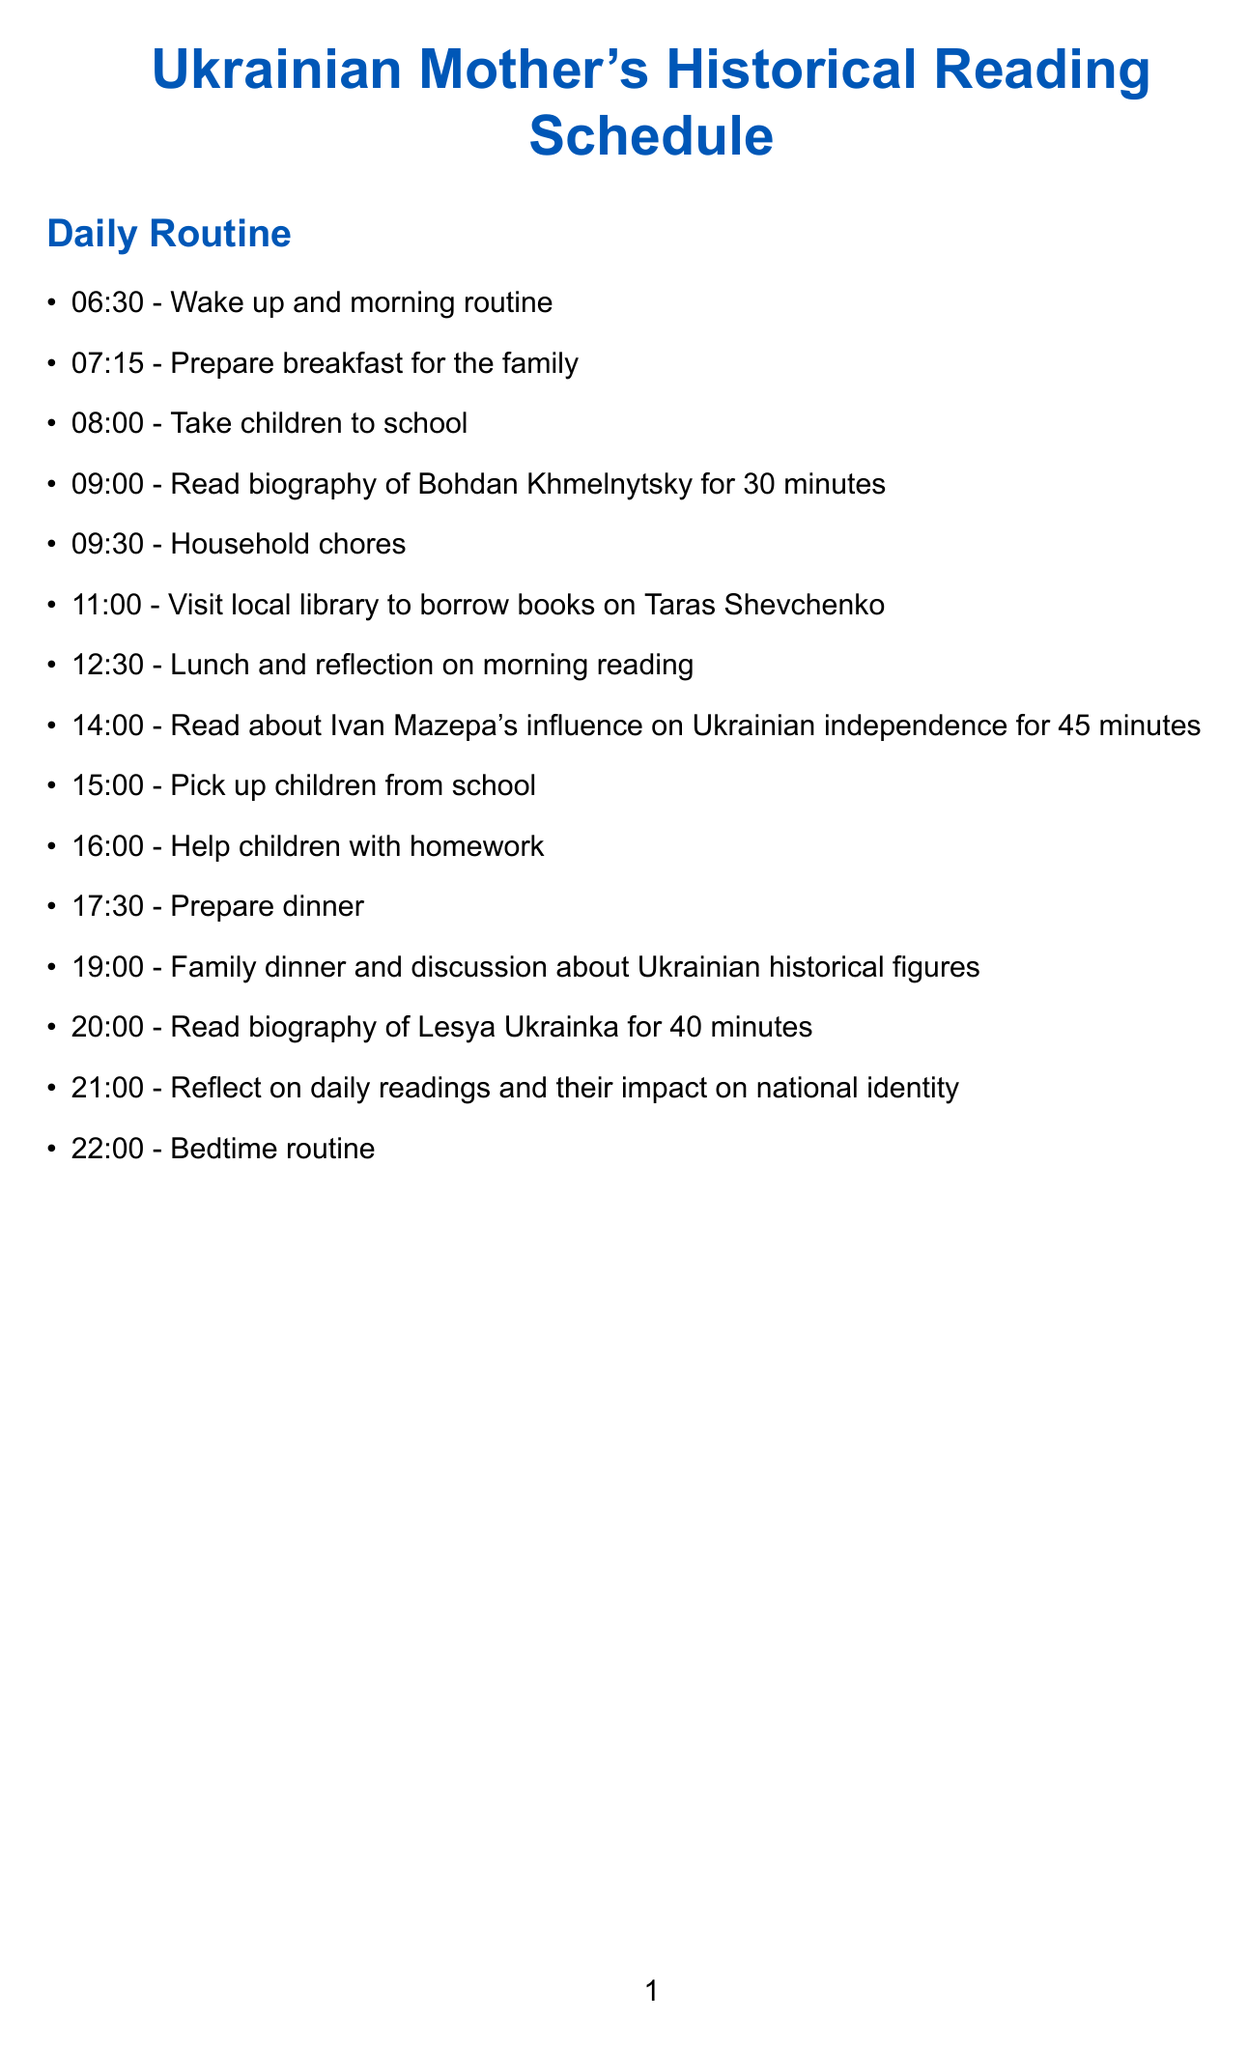What time does the family dinner take place? The document specifies the time scheduled for family dinner as 19:00.
Answer: 19:00 What biography is read on Monday morning? It mentions reading the biography of Bohdan Khmelnytsky for 30 minutes at 09:00.
Answer: Bohdan Khmelnytsky Which author wrote about Lesya Ukrainka? The reading list includes "Lesia Ukrainka: Life and Work" by Constantine H. Andrusyshen.
Answer: Constantine H. Andrusyshen What is the focus for Sunday’s family discussion? The document states the focus as “Family discussion on weekly learnings about Ukrainian historical figures.”
Answer: Family discussion on weekly learnings about Ukrainian historical figures How long is the reading session about Ivan Mazepa? The document indicates that the reading session about Ivan Mazepa lasts for 45 minutes starting at 14:00.
Answer: 45 minutes What time is set aside for reflection on daily readings? The schedule designates 21:00 for reflection on daily readings and their impact on national identity.
Answer: 21:00 